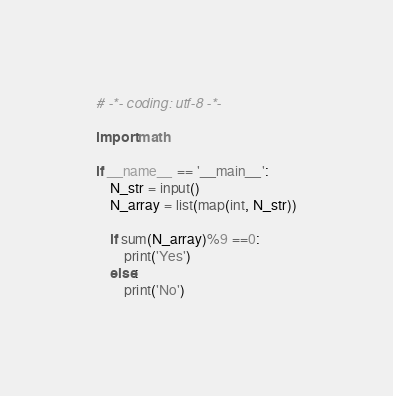Convert code to text. <code><loc_0><loc_0><loc_500><loc_500><_Python_># -*- coding: utf-8 -*-

import math

if __name__ == '__main__':
    N_str = input()
    N_array = list(map(int, N_str))
    
    if sum(N_array)%9 ==0:
        print('Yes')
    else:
        print('No')</code> 